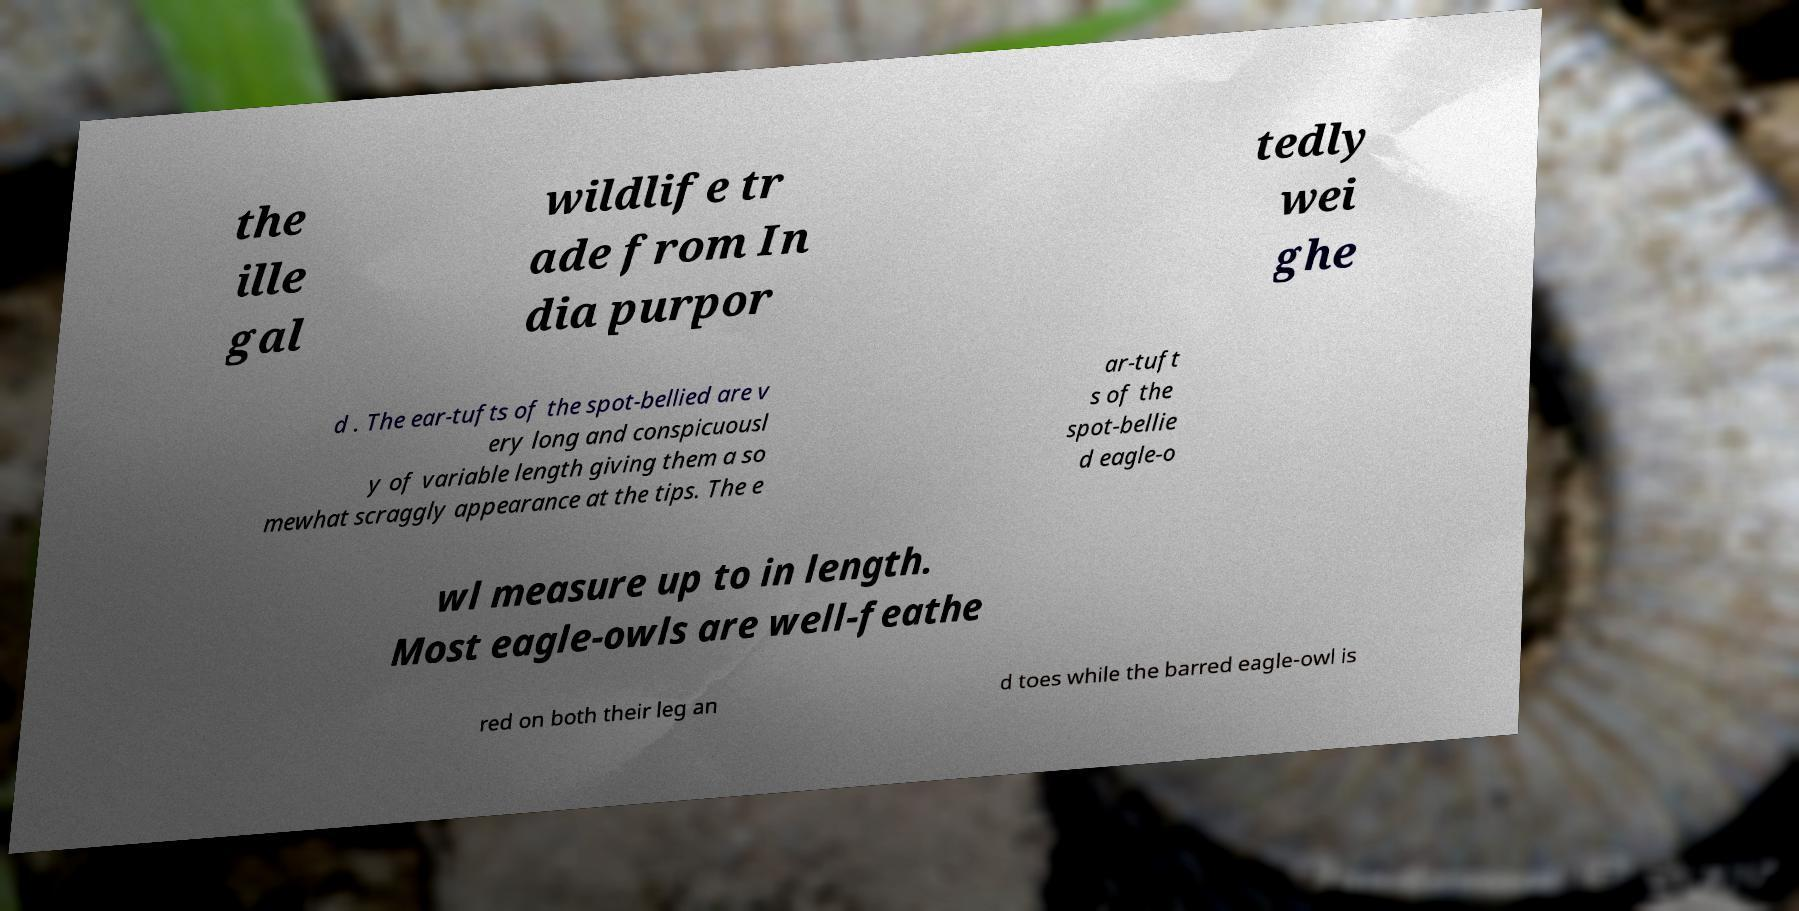What messages or text are displayed in this image? I need them in a readable, typed format. the ille gal wildlife tr ade from In dia purpor tedly wei ghe d . The ear-tufts of the spot-bellied are v ery long and conspicuousl y of variable length giving them a so mewhat scraggly appearance at the tips. The e ar-tuft s of the spot-bellie d eagle-o wl measure up to in length. Most eagle-owls are well-feathe red on both their leg an d toes while the barred eagle-owl is 